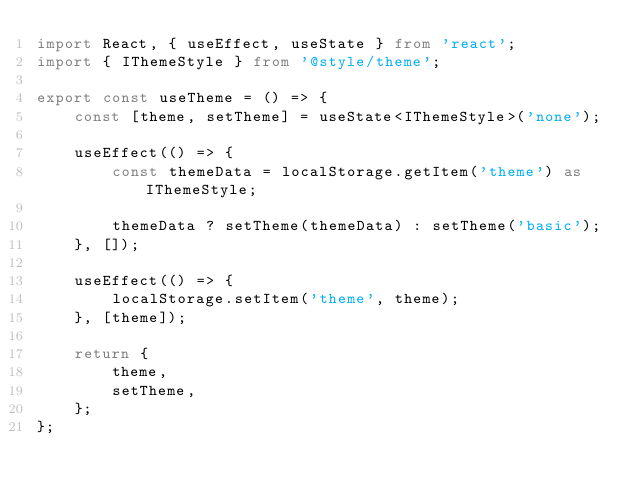Convert code to text. <code><loc_0><loc_0><loc_500><loc_500><_TypeScript_>import React, { useEffect, useState } from 'react';
import { IThemeStyle } from '@style/theme';

export const useTheme = () => {
    const [theme, setTheme] = useState<IThemeStyle>('none');

    useEffect(() => {
        const themeData = localStorage.getItem('theme') as IThemeStyle;

        themeData ? setTheme(themeData) : setTheme('basic');
    }, []);

    useEffect(() => {
        localStorage.setItem('theme', theme);
    }, [theme]);

    return {
        theme,
        setTheme,
    };
};
</code> 